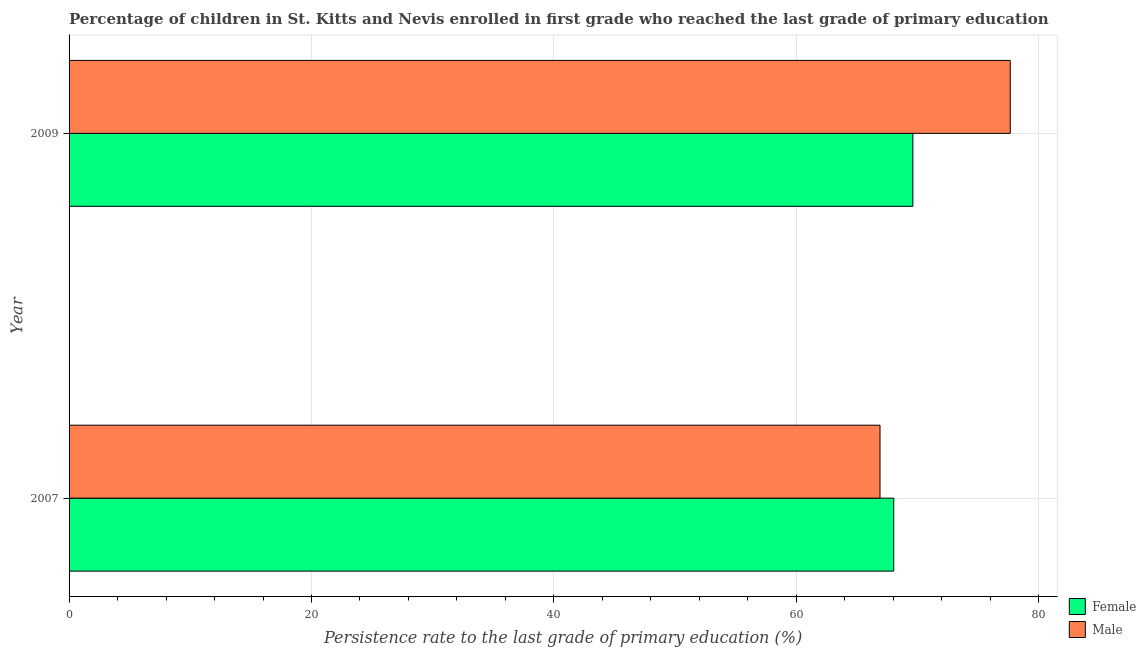How many different coloured bars are there?
Make the answer very short. 2. How many groups of bars are there?
Your response must be concise. 2. Are the number of bars per tick equal to the number of legend labels?
Keep it short and to the point. Yes. Are the number of bars on each tick of the Y-axis equal?
Your answer should be compact. Yes. How many bars are there on the 2nd tick from the bottom?
Offer a terse response. 2. What is the label of the 1st group of bars from the top?
Make the answer very short. 2009. What is the persistence rate of male students in 2009?
Keep it short and to the point. 77.65. Across all years, what is the maximum persistence rate of male students?
Offer a very short reply. 77.65. Across all years, what is the minimum persistence rate of female students?
Provide a short and direct response. 68.04. In which year was the persistence rate of female students minimum?
Your response must be concise. 2007. What is the total persistence rate of male students in the graph?
Offer a very short reply. 144.55. What is the difference between the persistence rate of male students in 2007 and that in 2009?
Offer a very short reply. -10.74. What is the difference between the persistence rate of male students in 2009 and the persistence rate of female students in 2007?
Provide a succinct answer. 9.61. What is the average persistence rate of female students per year?
Your response must be concise. 68.82. In the year 2007, what is the difference between the persistence rate of male students and persistence rate of female students?
Your answer should be very brief. -1.13. In how many years, is the persistence rate of male students greater than 60 %?
Provide a succinct answer. 2. In how many years, is the persistence rate of male students greater than the average persistence rate of male students taken over all years?
Your answer should be compact. 1. What does the 2nd bar from the top in 2007 represents?
Offer a very short reply. Female. How are the legend labels stacked?
Ensure brevity in your answer.  Vertical. What is the title of the graph?
Offer a terse response. Percentage of children in St. Kitts and Nevis enrolled in first grade who reached the last grade of primary education. Does "Foreign liabilities" appear as one of the legend labels in the graph?
Your response must be concise. No. What is the label or title of the X-axis?
Your answer should be compact. Persistence rate to the last grade of primary education (%). What is the label or title of the Y-axis?
Your response must be concise. Year. What is the Persistence rate to the last grade of primary education (%) in Female in 2007?
Make the answer very short. 68.04. What is the Persistence rate to the last grade of primary education (%) in Male in 2007?
Your answer should be compact. 66.9. What is the Persistence rate to the last grade of primary education (%) of Female in 2009?
Your answer should be very brief. 69.61. What is the Persistence rate to the last grade of primary education (%) in Male in 2009?
Offer a terse response. 77.65. Across all years, what is the maximum Persistence rate to the last grade of primary education (%) of Female?
Your answer should be compact. 69.61. Across all years, what is the maximum Persistence rate to the last grade of primary education (%) of Male?
Offer a very short reply. 77.65. Across all years, what is the minimum Persistence rate to the last grade of primary education (%) of Female?
Provide a succinct answer. 68.04. Across all years, what is the minimum Persistence rate to the last grade of primary education (%) in Male?
Keep it short and to the point. 66.9. What is the total Persistence rate to the last grade of primary education (%) of Female in the graph?
Offer a terse response. 137.65. What is the total Persistence rate to the last grade of primary education (%) of Male in the graph?
Give a very brief answer. 144.55. What is the difference between the Persistence rate to the last grade of primary education (%) in Female in 2007 and that in 2009?
Provide a succinct answer. -1.58. What is the difference between the Persistence rate to the last grade of primary education (%) in Male in 2007 and that in 2009?
Offer a very short reply. -10.74. What is the difference between the Persistence rate to the last grade of primary education (%) of Female in 2007 and the Persistence rate to the last grade of primary education (%) of Male in 2009?
Give a very brief answer. -9.61. What is the average Persistence rate to the last grade of primary education (%) of Female per year?
Keep it short and to the point. 68.82. What is the average Persistence rate to the last grade of primary education (%) in Male per year?
Your answer should be very brief. 72.28. In the year 2007, what is the difference between the Persistence rate to the last grade of primary education (%) in Female and Persistence rate to the last grade of primary education (%) in Male?
Provide a short and direct response. 1.13. In the year 2009, what is the difference between the Persistence rate to the last grade of primary education (%) of Female and Persistence rate to the last grade of primary education (%) of Male?
Offer a very short reply. -8.04. What is the ratio of the Persistence rate to the last grade of primary education (%) of Female in 2007 to that in 2009?
Offer a very short reply. 0.98. What is the ratio of the Persistence rate to the last grade of primary education (%) in Male in 2007 to that in 2009?
Give a very brief answer. 0.86. What is the difference between the highest and the second highest Persistence rate to the last grade of primary education (%) in Female?
Your answer should be compact. 1.58. What is the difference between the highest and the second highest Persistence rate to the last grade of primary education (%) of Male?
Keep it short and to the point. 10.74. What is the difference between the highest and the lowest Persistence rate to the last grade of primary education (%) of Female?
Keep it short and to the point. 1.58. What is the difference between the highest and the lowest Persistence rate to the last grade of primary education (%) of Male?
Offer a very short reply. 10.74. 